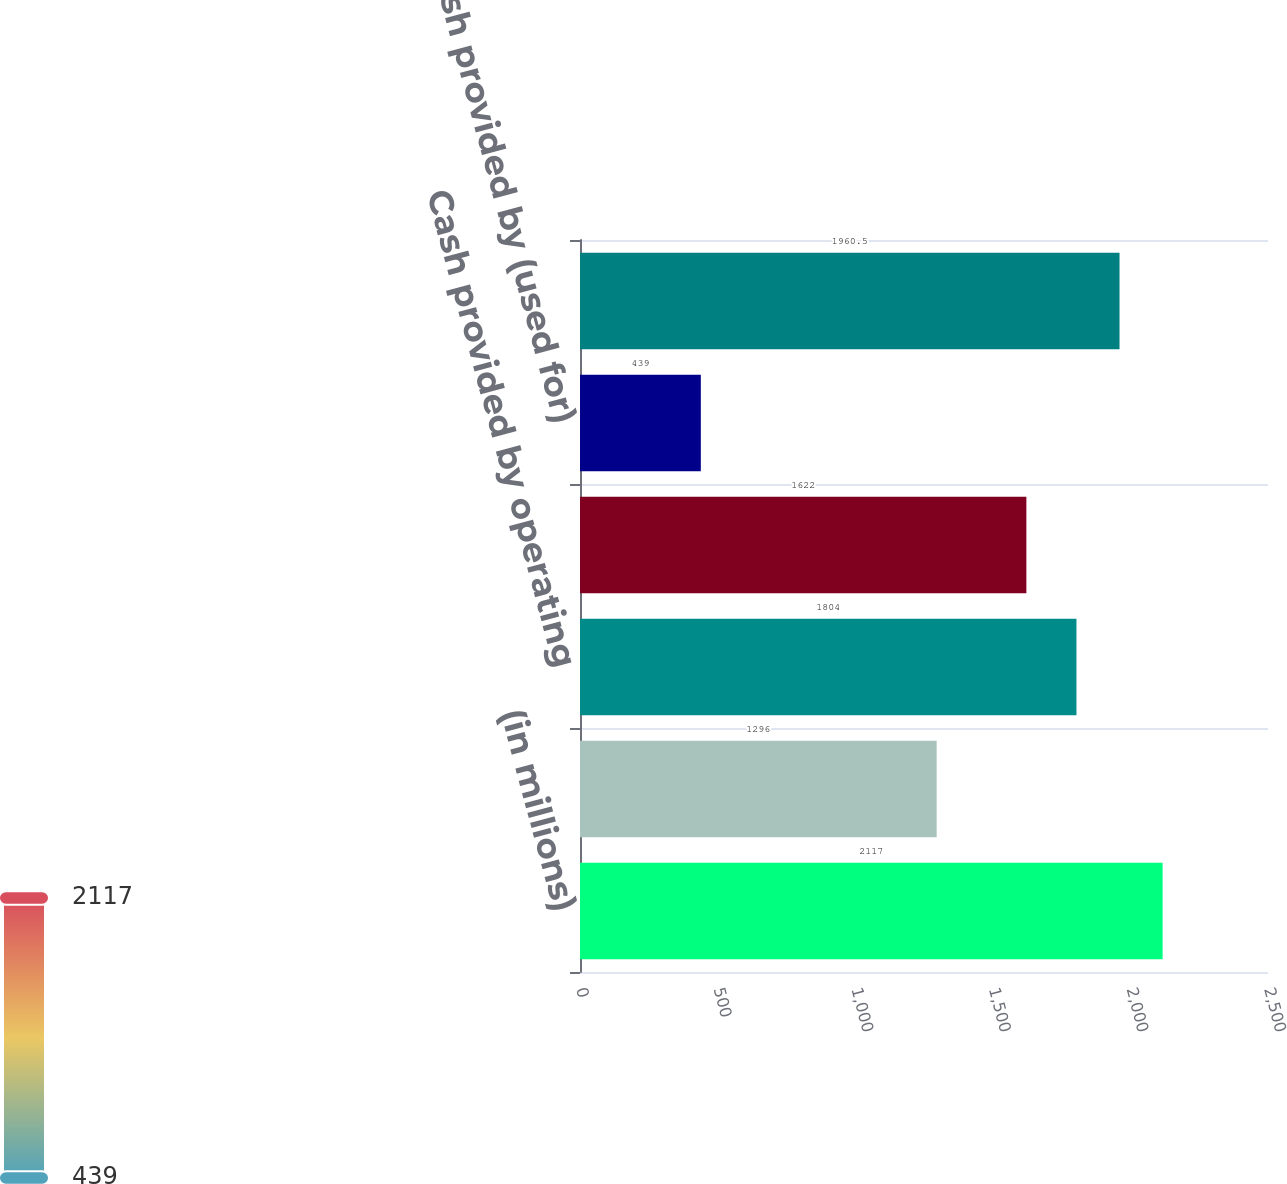Convert chart to OTSL. <chart><loc_0><loc_0><loc_500><loc_500><bar_chart><fcel>(in millions)<fcel>Cash and cash equivalents<fcel>Cash provided by operating<fcel>Cash used for investing<fcel>Cash provided by (used for)<fcel>EBITDA 2<nl><fcel>2117<fcel>1296<fcel>1804<fcel>1622<fcel>439<fcel>1960.5<nl></chart> 